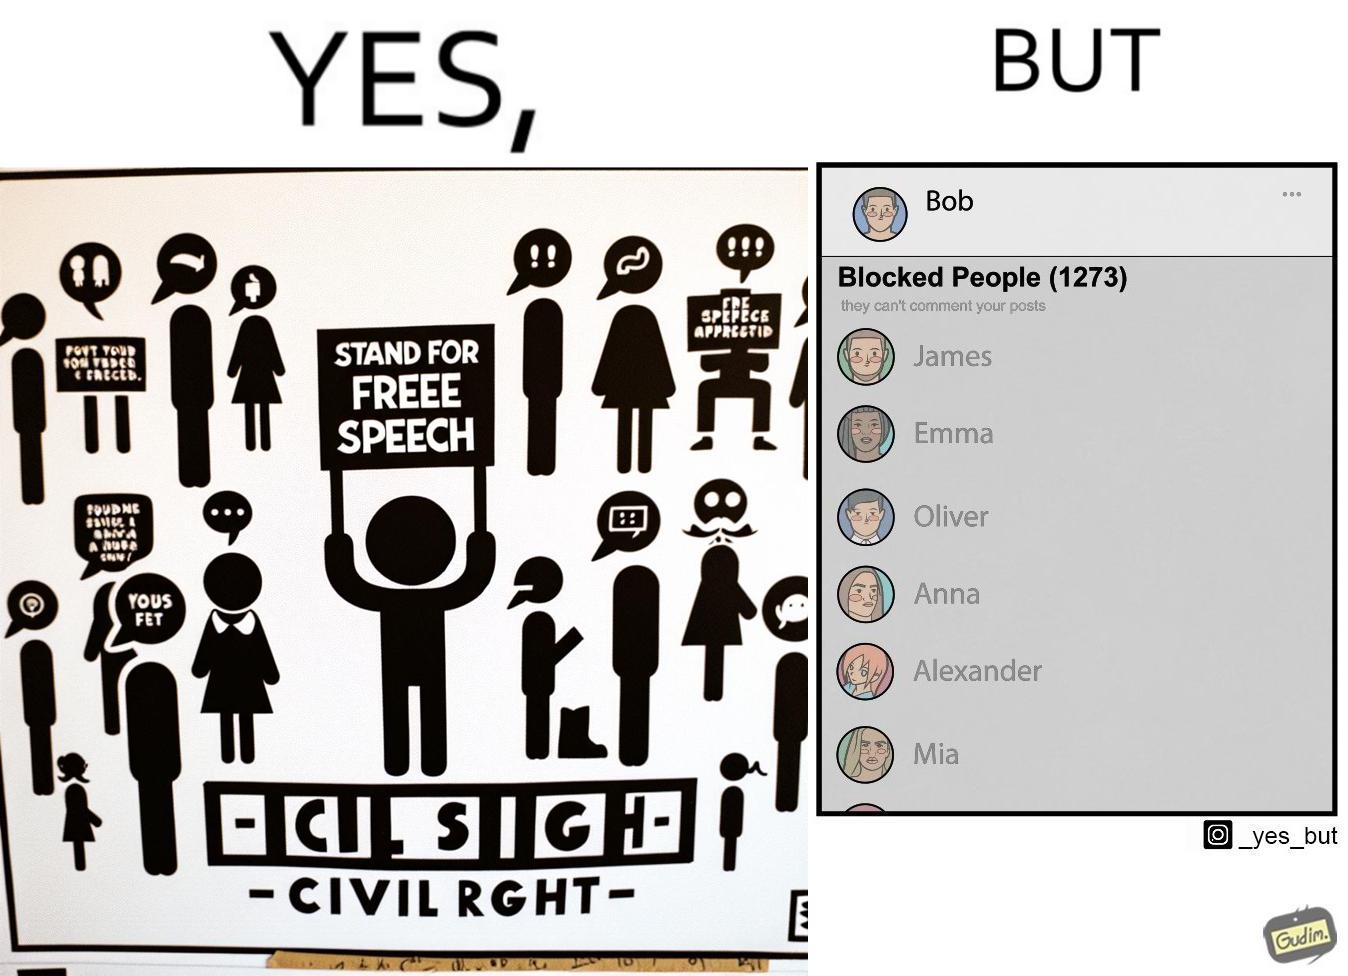Describe what you see in this image. The images are funny since even though someone like "Bob" shows support for free speech as a civil right, he is not ready to deal with the consequences of free speech and chooses to not be spoken to by certain people. He thus blocks people from contacting him on his phone. 